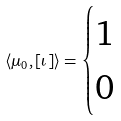Convert formula to latex. <formula><loc_0><loc_0><loc_500><loc_500>\langle \mu _ { 0 } , [ \iota ] \rangle = \begin{cases} 1 & \\ 0 & \end{cases}</formula> 